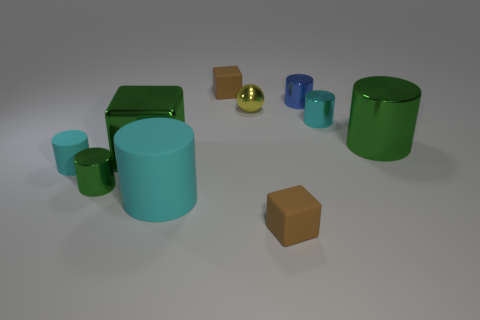How many cyan cylinders must be subtracted to get 1 cyan cylinders? 2 Subtract all brown balls. How many cyan cylinders are left? 3 Subtract all green cylinders. How many cylinders are left? 4 Subtract 3 cylinders. How many cylinders are left? 3 Subtract all big green metallic cylinders. How many cylinders are left? 5 Subtract all purple cylinders. Subtract all green spheres. How many cylinders are left? 6 Subtract all cubes. How many objects are left? 7 Add 5 large cyan objects. How many large cyan objects exist? 6 Subtract 0 gray balls. How many objects are left? 10 Subtract all large cyan rubber things. Subtract all small yellow shiny spheres. How many objects are left? 8 